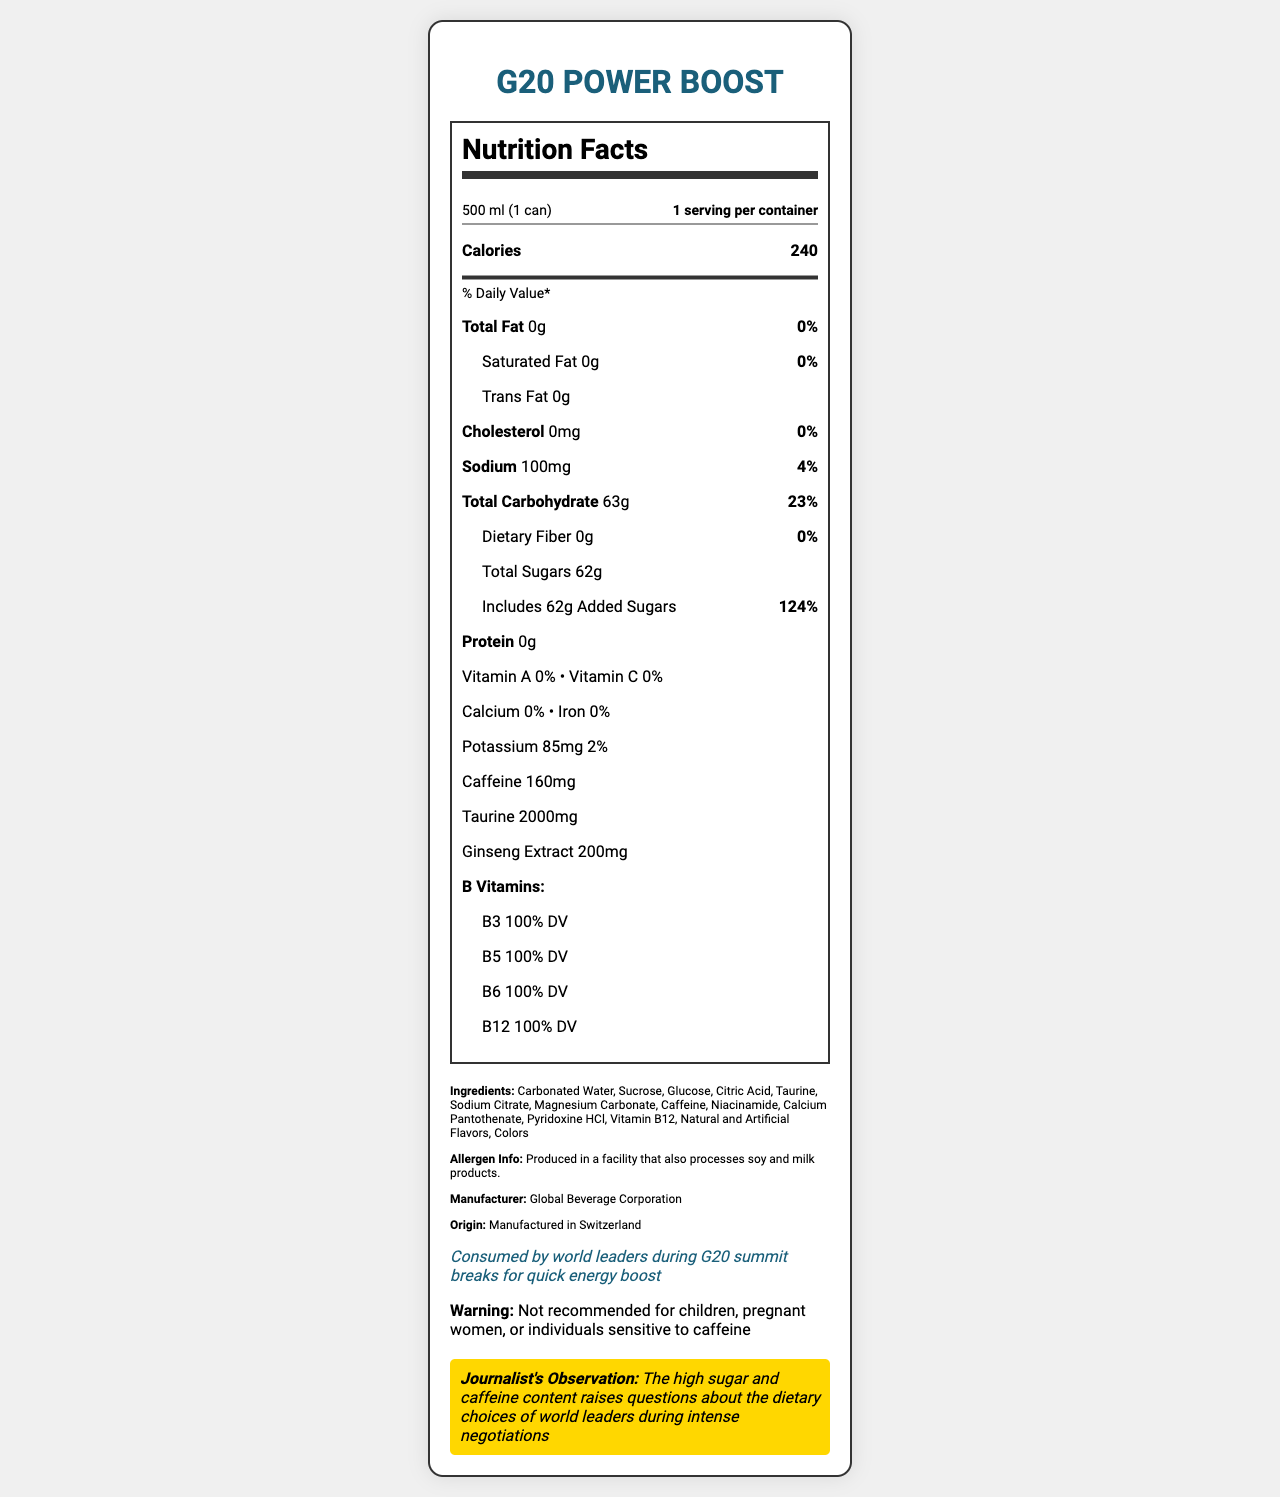what is the serving size for G20 Power Boost? The serving size is specified directly under the product name as "500 ml (1 can)".
Answer: 500 ml (1 can) how many calories are in one serving? The nutrition label shows that one serving contains 240 calories.
Answer: 240 how much sodium is in the drink? The document indicates that the sodium content per serving is 100mg.
Answer: 100mg how many grams of total sugars and added sugars are in the drink? Both total sugars and added sugars are listed as 62g.
Answer: 62g total sugars, 62g added sugars how much caffeine does the drink contain? It states that the caffeine content is 160mg.
Answer: 160mg which B vitamin is NOT included in the drink? The listed B vitamins are B3, B5, B6, and B12. B1 (Thiamine) is not included.
Answer: B1 (Thiamine) where is the G20 Power Boost manufactured? The origin of the beverage is stated as "Manufactured in Switzerland".
Answer: Switzerland what percentage of daily value of sodium does the drink provide? A. 2% B. 4% C. 10% The document indicates that the sodium content is 4% of the daily value.
Answer: B. 4% what percentage of the daily value of added sugars does one serving contain? A. 62% B. 100% C. 124% The document shows that added sugars make up 124% of the daily value.
Answer: C. 124% which of the following is not an ingredient in the drink? A. Sucrose B. Glucose C. Aspartame Aspartame is not listed among the ingredients.
Answer: C. Aspartame is this drink recommended for children or pregnant women? The warning section states that the drink is not recommended for children, pregnant women, or individuals sensitive to caffeine.
Answer: No summarize the main points of the document The document consists of a detailed nutritional breakdown, ingredient list, and special notes about the G20 Power Boost energy drink. It emphasizes the high caffeine and sugar content while providing a cautionary note regarding its consumption by sensitive groups.
Answer: The document provides the nutritional facts for G20 Power Boost, an energy drink consumed by world leaders during the G20 summit. It includes details on serving size, caloric content, vitamins, and mineral values, as well as ingredients and allergen information. The drink contains high levels of caffeine and added sugars. There are specific warnings against consumption by certain groups. The document also makes a journalist's observation on the high sugar and caffeine content. what is the potassium content of the drink? The potassium content is listed as 85mg.
Answer: 85mg does the drink contain any dietary fiber? According to the document, the dietary fiber content is 0g.
Answer: No what is the special note about the drink? The special note section specifically mentions the context in which the drink is consumed.
Answer: Consumed by world leaders during G20 summit breaks for quick energy boost is the document sufficient to assess the overall healthiness of the drink? The document provides detailed nutritional information and ingredients, but assessing the overall healthiness would require additional context such as dietary needs, individual health conditions, and overall consumption patterns.
Answer: No 